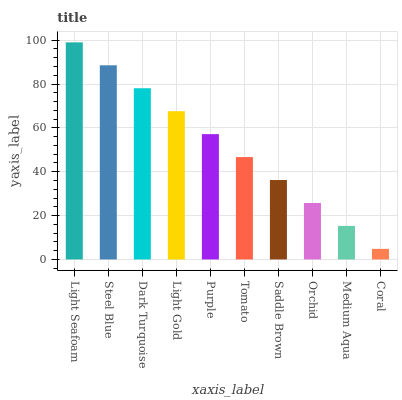Is Coral the minimum?
Answer yes or no. Yes. Is Light Seafoam the maximum?
Answer yes or no. Yes. Is Steel Blue the minimum?
Answer yes or no. No. Is Steel Blue the maximum?
Answer yes or no. No. Is Light Seafoam greater than Steel Blue?
Answer yes or no. Yes. Is Steel Blue less than Light Seafoam?
Answer yes or no. Yes. Is Steel Blue greater than Light Seafoam?
Answer yes or no. No. Is Light Seafoam less than Steel Blue?
Answer yes or no. No. Is Purple the high median?
Answer yes or no. Yes. Is Tomato the low median?
Answer yes or no. Yes. Is Light Gold the high median?
Answer yes or no. No. Is Orchid the low median?
Answer yes or no. No. 